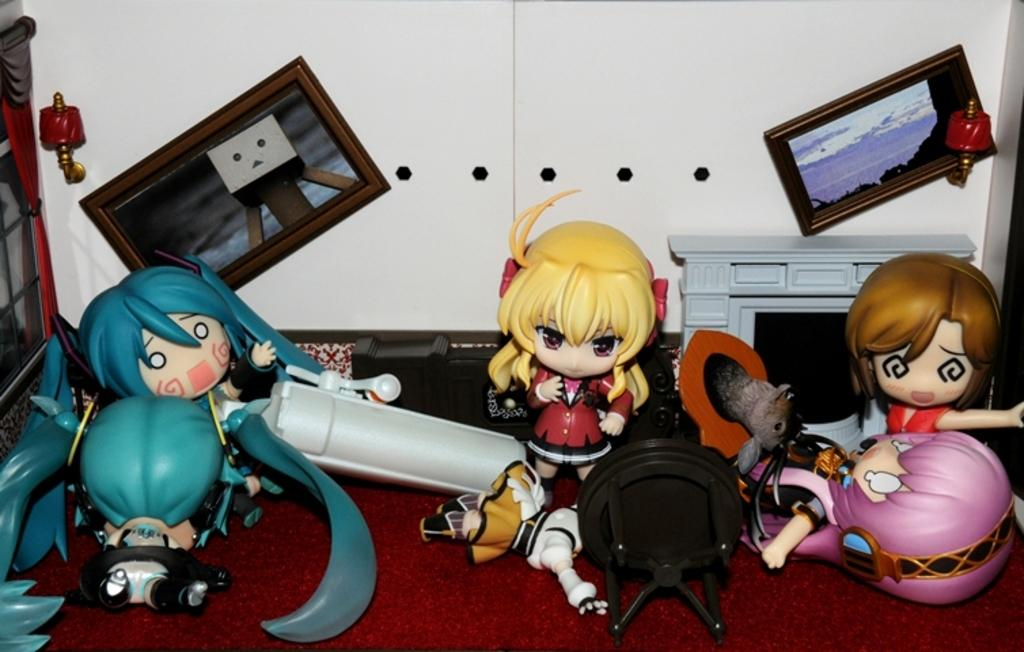What objects can be seen in the image? There are toys in the image. What can be observed about the wall in the image? There is a white color wall in the image. Are there any decorations on the wall in the image? Yes, there are photos on the wall in the image. What type of knee injury is visible in the image? There is no knee injury present in the image. Can you tell me who made the request for the photos to be hung on the wall? The image does not provide information about who made the request for the photos to be hung on the wall. 